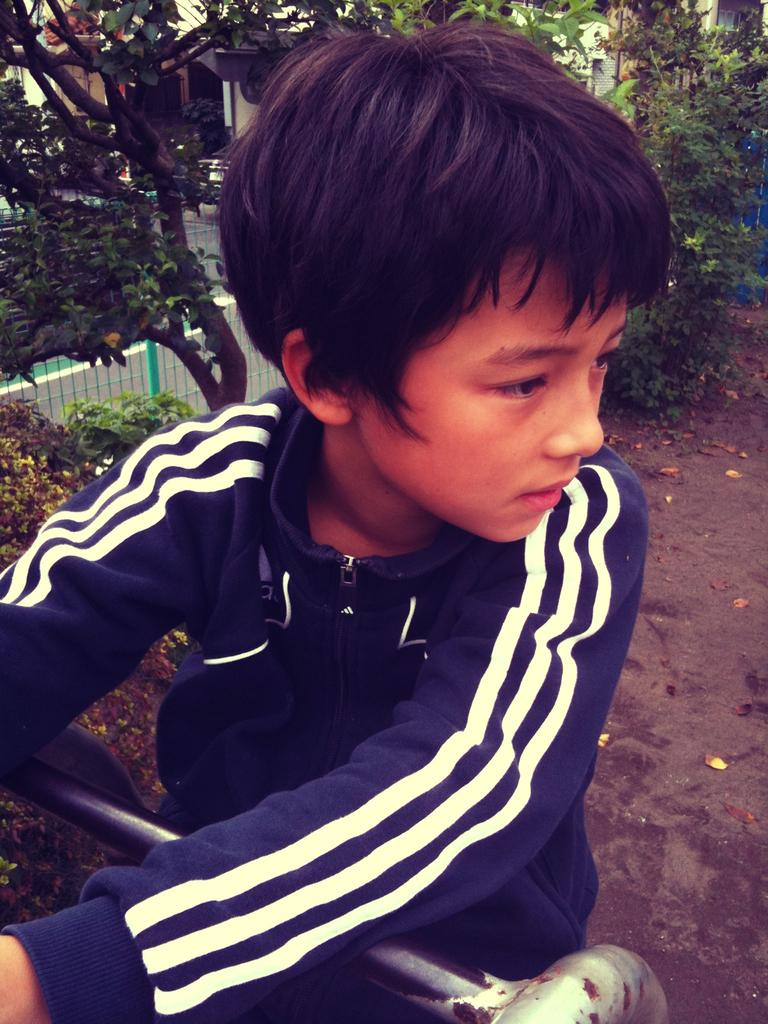Who is in the image? There is a boy in the image. What is the boy wearing? The boy is wearing a t-shirt. Where is the boy located in relation to the pipe? The boy is standing near a pipe. What can be seen in the background of the image? Trees, at least one building, plants, and wooden fencing are visible in the background of the image. What type of glue is the boy using to attach the lace to the look in the image? There is no glue, lace, or look present in the image; the boy is simply standing near a pipe. 